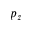<formula> <loc_0><loc_0><loc_500><loc_500>p _ { z }</formula> 